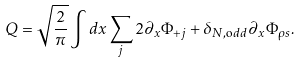<formula> <loc_0><loc_0><loc_500><loc_500>Q = \sqrt { \frac { 2 } { \pi } } \int d x \sum _ { j } 2 \partial _ { x } \Phi _ { + j } + \delta _ { N , { \mathrm o d d } } \partial _ { x } \Phi _ { \rho s } .</formula> 